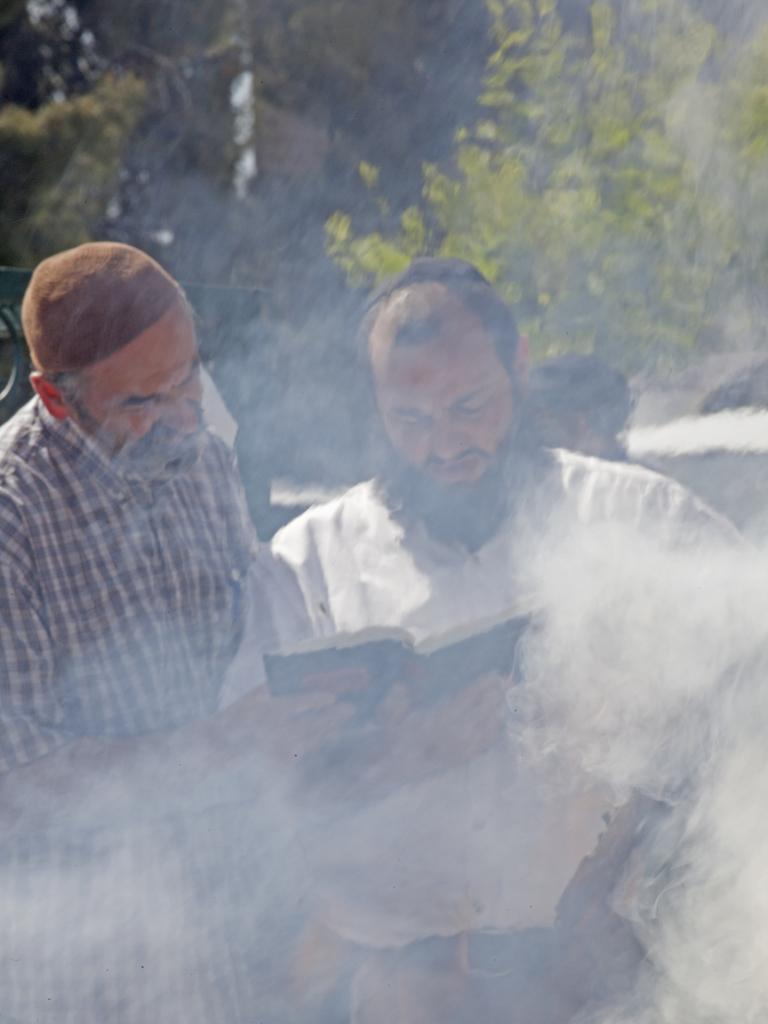How many people are in the foreground of the image? There are two persons standing in the foreground of the image. What is one of the persons holding? One person is holding a book. What can be seen in the background of the image? There are trees and fog visible in the background of the image. What degree is the person holding the book pursuing in the image? There is no information about a degree in the image, as it only shows two people standing and one person holding a book. 